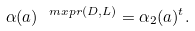<formula> <loc_0><loc_0><loc_500><loc_500>\alpha ( a ) ^ { \ m x { p r } ( D , L ) } = \alpha _ { 2 } ( a ) ^ { t } .</formula> 